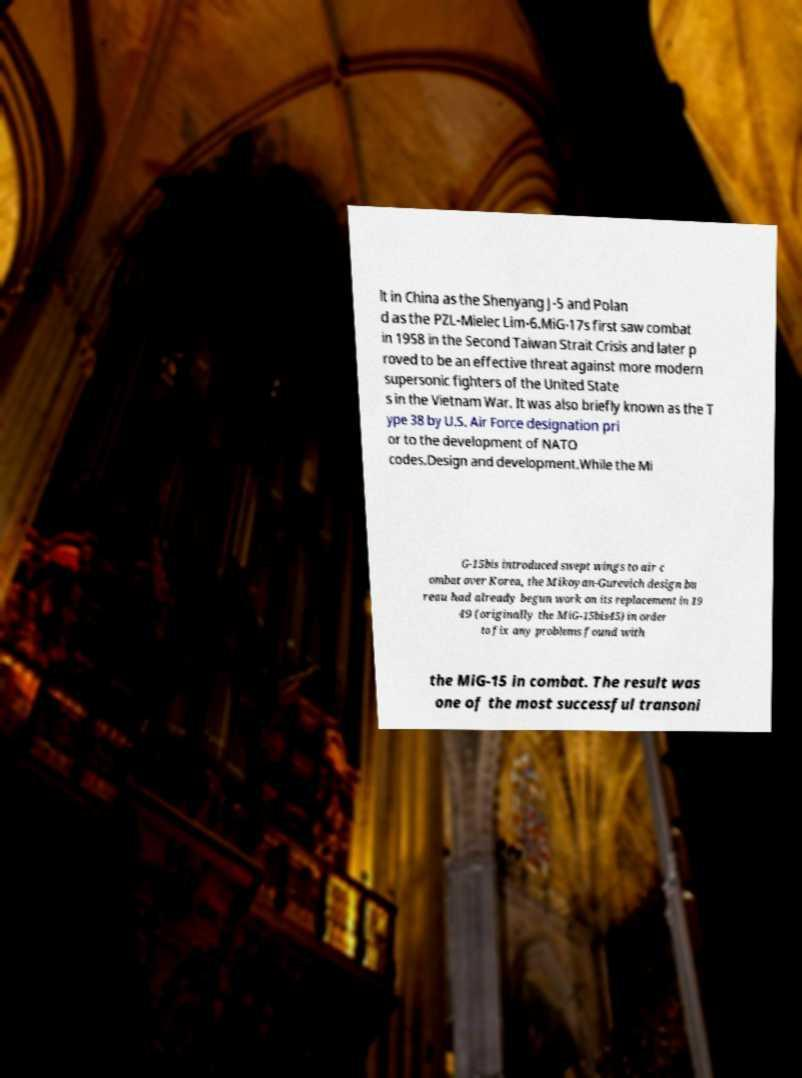Could you extract and type out the text from this image? lt in China as the Shenyang J-5 and Polan d as the PZL-Mielec Lim-6.MiG-17s first saw combat in 1958 in the Second Taiwan Strait Crisis and later p roved to be an effective threat against more modern supersonic fighters of the United State s in the Vietnam War. It was also briefly known as the T ype 38 by U.S. Air Force designation pri or to the development of NATO codes.Design and development.While the Mi G-15bis introduced swept wings to air c ombat over Korea, the Mikoyan-Gurevich design bu reau had already begun work on its replacement in 19 49 (originally the MiG-15bis45) in order to fix any problems found with the MiG-15 in combat. The result was one of the most successful transoni 